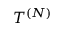Convert formula to latex. <formula><loc_0><loc_0><loc_500><loc_500>T ^ { ( N ) }</formula> 